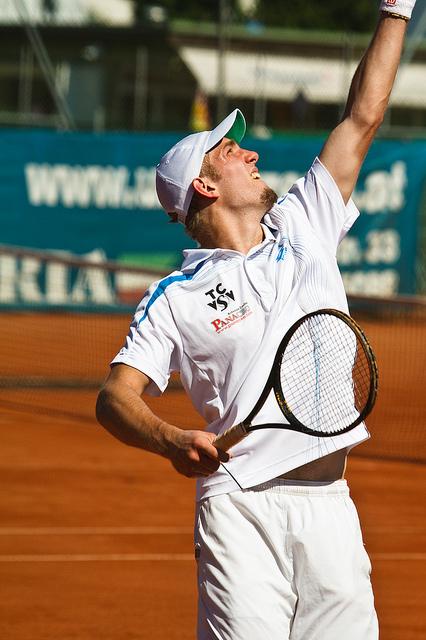Is all white attire required for players of this sport?
Keep it brief. No. What game is being played?
Be succinct. Tennis. What color is the man's hat?
Answer briefly. White. What sport is this man playing?
Give a very brief answer. Tennis. 